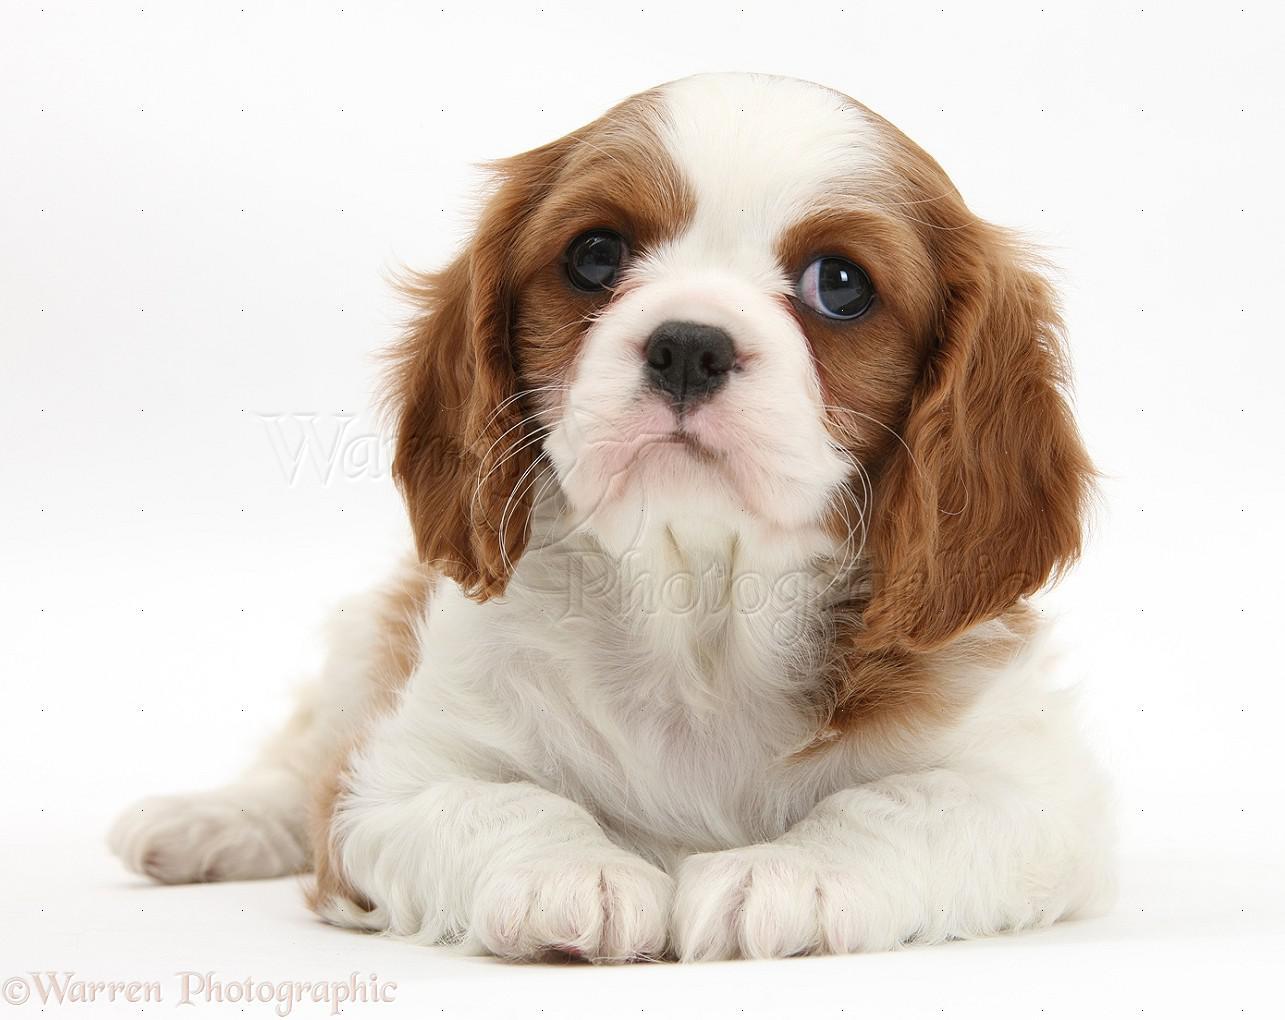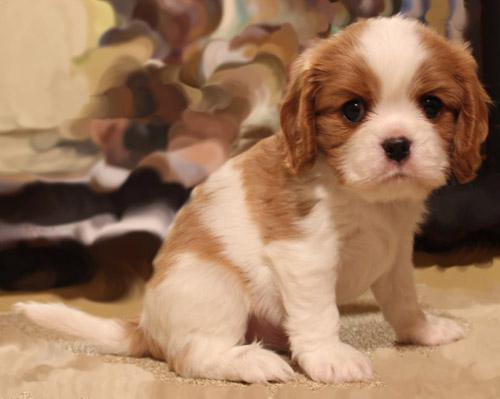The first image is the image on the left, the second image is the image on the right. Evaluate the accuracy of this statement regarding the images: "There are three dogs". Is it true? Answer yes or no. No. 